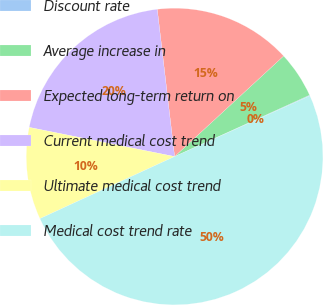<chart> <loc_0><loc_0><loc_500><loc_500><pie_chart><fcel>Discount rate<fcel>Average increase in<fcel>Expected long-term return on<fcel>Current medical cost trend<fcel>Ultimate medical cost trend<fcel>Medical cost trend rate<nl><fcel>0.08%<fcel>5.06%<fcel>15.01%<fcel>19.98%<fcel>10.03%<fcel>49.84%<nl></chart> 